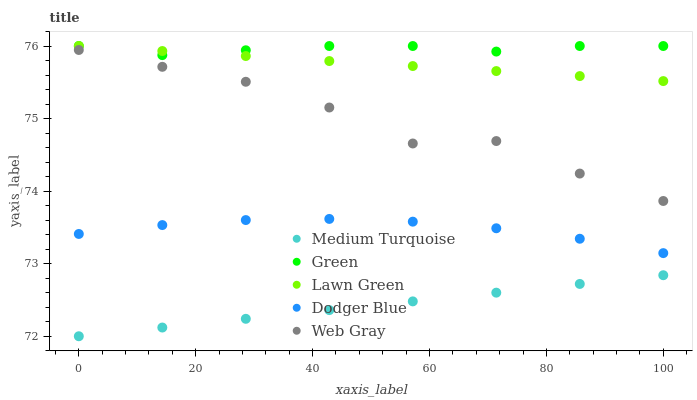Does Medium Turquoise have the minimum area under the curve?
Answer yes or no. Yes. Does Green have the maximum area under the curve?
Answer yes or no. Yes. Does Web Gray have the minimum area under the curve?
Answer yes or no. No. Does Web Gray have the maximum area under the curve?
Answer yes or no. No. Is Lawn Green the smoothest?
Answer yes or no. Yes. Is Web Gray the roughest?
Answer yes or no. Yes. Is Green the smoothest?
Answer yes or no. No. Is Green the roughest?
Answer yes or no. No. Does Medium Turquoise have the lowest value?
Answer yes or no. Yes. Does Web Gray have the lowest value?
Answer yes or no. No. Does Green have the highest value?
Answer yes or no. Yes. Does Web Gray have the highest value?
Answer yes or no. No. Is Medium Turquoise less than Dodger Blue?
Answer yes or no. Yes. Is Dodger Blue greater than Medium Turquoise?
Answer yes or no. Yes. Does Green intersect Lawn Green?
Answer yes or no. Yes. Is Green less than Lawn Green?
Answer yes or no. No. Is Green greater than Lawn Green?
Answer yes or no. No. Does Medium Turquoise intersect Dodger Blue?
Answer yes or no. No. 